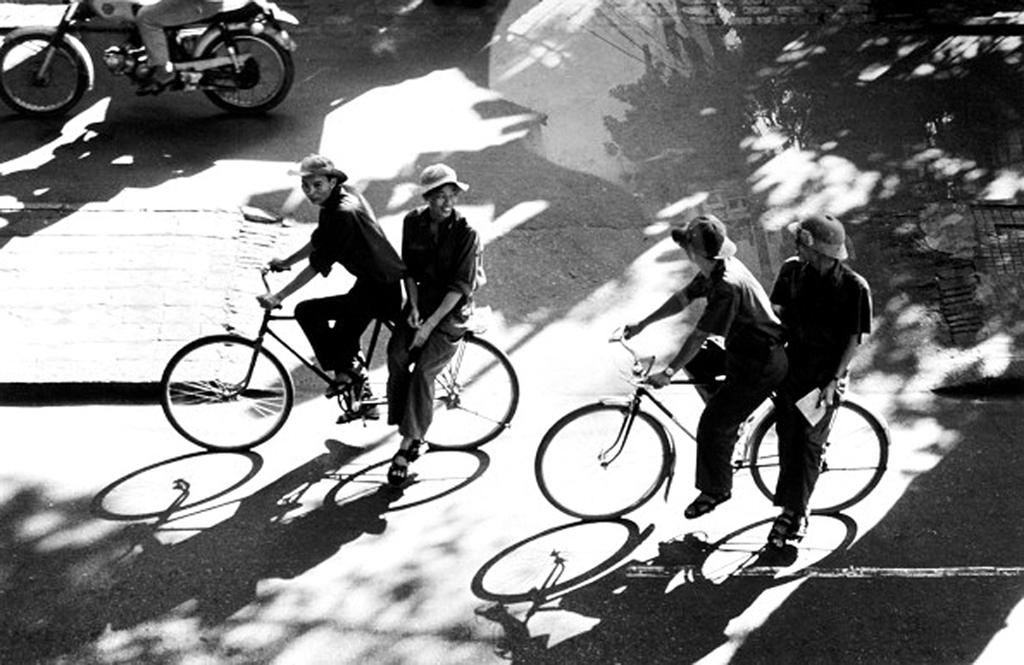What are the people in the image doing? The people in the image are on bicycles. Where are the people on bicycles located? The people are on a road. Is there any other vehicle visible in the image? Yes, there is a man on a motorcycle in the top left side corner of the image. What type of credit is being offered to the people on bicycles in the image? There is no mention of credit or any financial transaction in the image. 